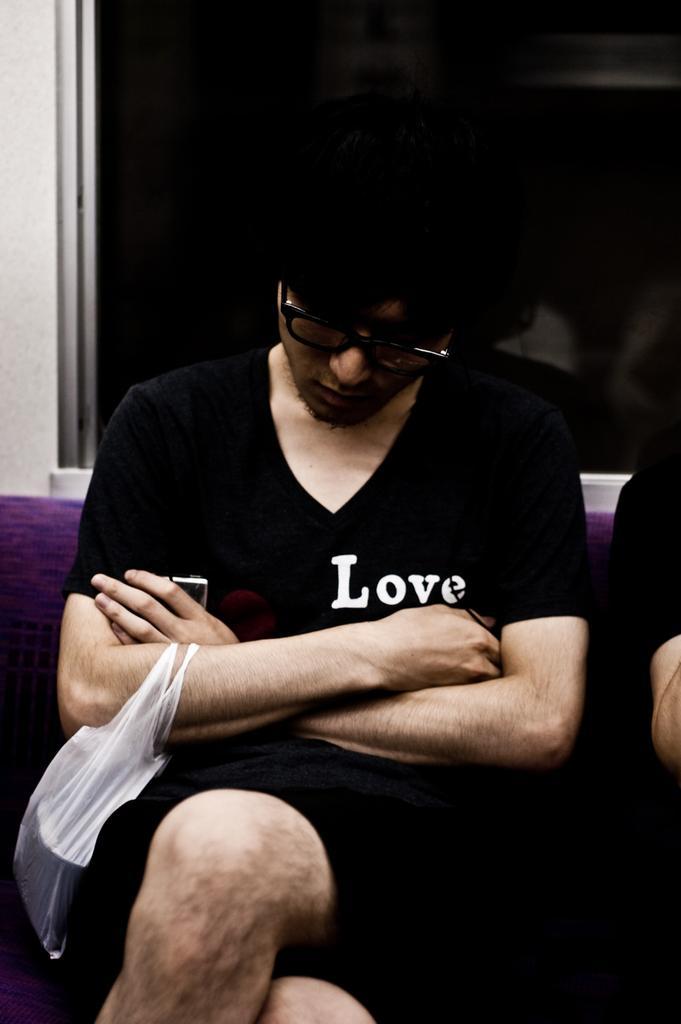In one or two sentences, can you explain what this image depicts? In this picture there is a man sitting on a sofa and carrying a cover, beside him we can see a hand of a person. In the background of the image we can see wall and glass window. 